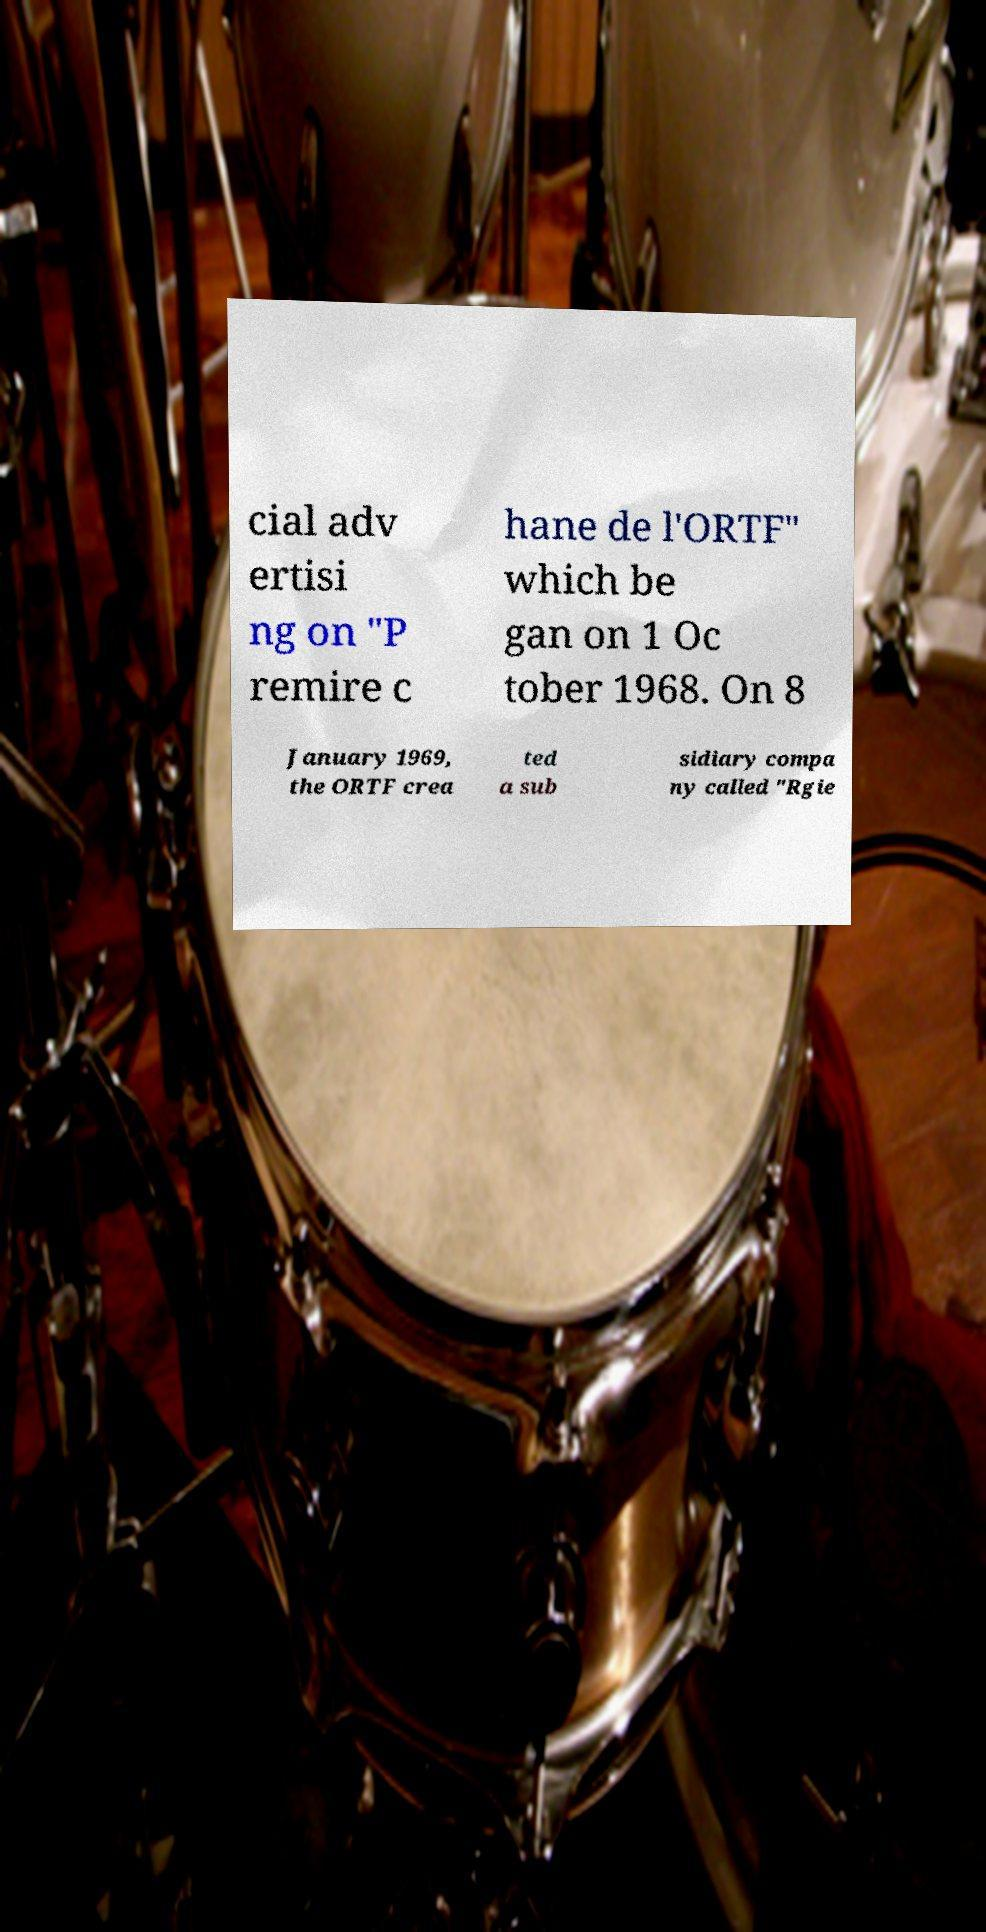For documentation purposes, I need the text within this image transcribed. Could you provide that? cial adv ertisi ng on "P remire c hane de l'ORTF" which be gan on 1 Oc tober 1968. On 8 January 1969, the ORTF crea ted a sub sidiary compa ny called "Rgie 